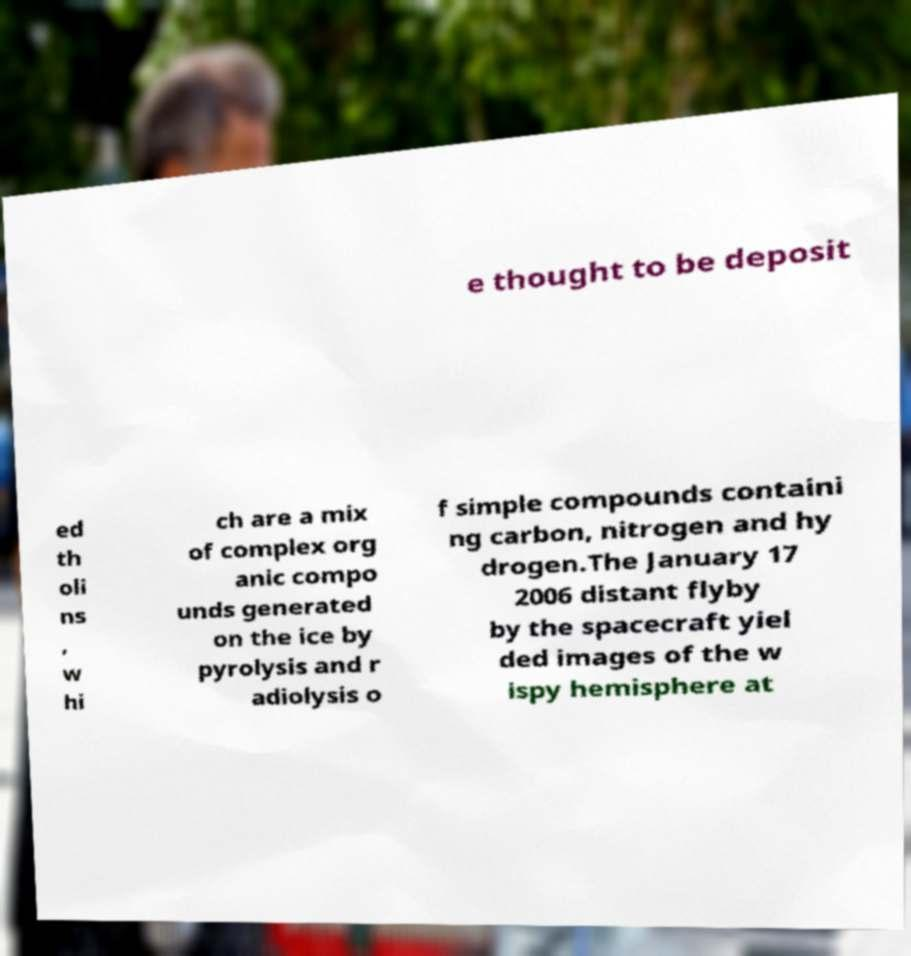Could you assist in decoding the text presented in this image and type it out clearly? e thought to be deposit ed th oli ns , w hi ch are a mix of complex org anic compo unds generated on the ice by pyrolysis and r adiolysis o f simple compounds containi ng carbon, nitrogen and hy drogen.The January 17 2006 distant flyby by the spacecraft yiel ded images of the w ispy hemisphere at 